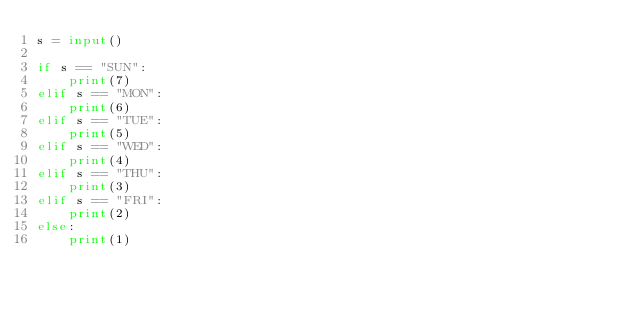Convert code to text. <code><loc_0><loc_0><loc_500><loc_500><_Python_>s = input()

if s == "SUN":
    print(7)
elif s == "MON":
    print(6)
elif s == "TUE":
    print(5)
elif s == "WED":
    print(4)
elif s == "THU":
    print(3)
elif s == "FRI":
    print(2)
else:
    print(1)</code> 